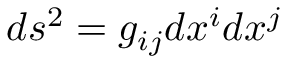Convert formula to latex. <formula><loc_0><loc_0><loc_500><loc_500>d s ^ { 2 } = g _ { i j } d x ^ { i } d x ^ { j }</formula> 